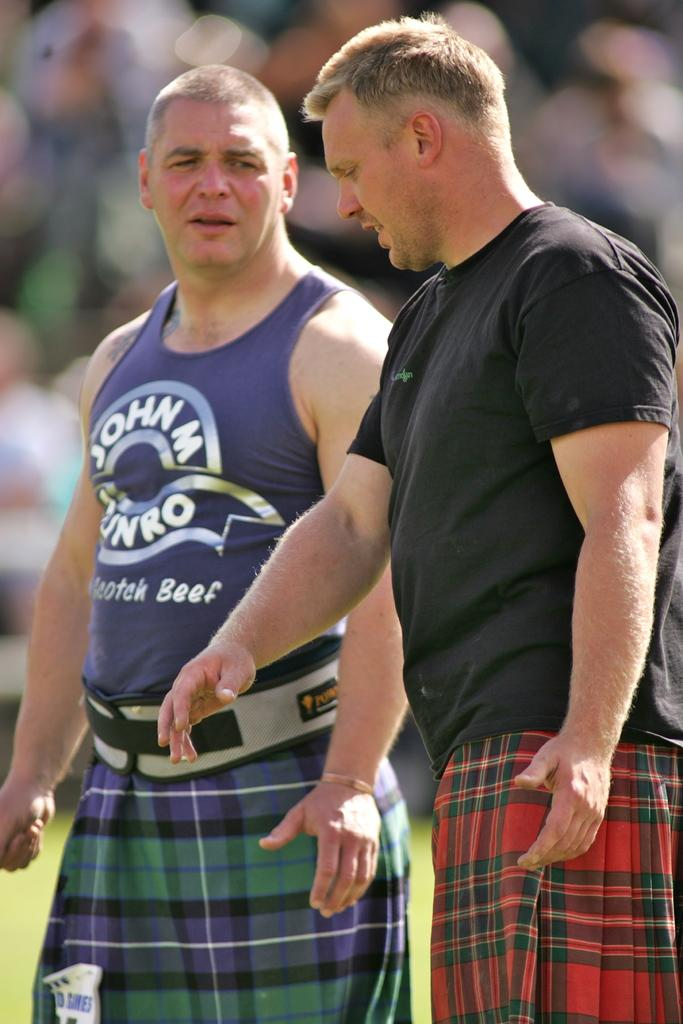How many people are in the image? There are two people in the image. What are the two people doing? The two people are standing and talking to each other. Can you describe the background of the image? The background of the image is blurred. What type of office equipment can be seen in the image? There is no office equipment present in the image. What is the spade used for in the image? There is no spade present in the image. Is the sun visible in the image? The provided facts do not mention the sun, so we cannot determine if it is visible in the image. 